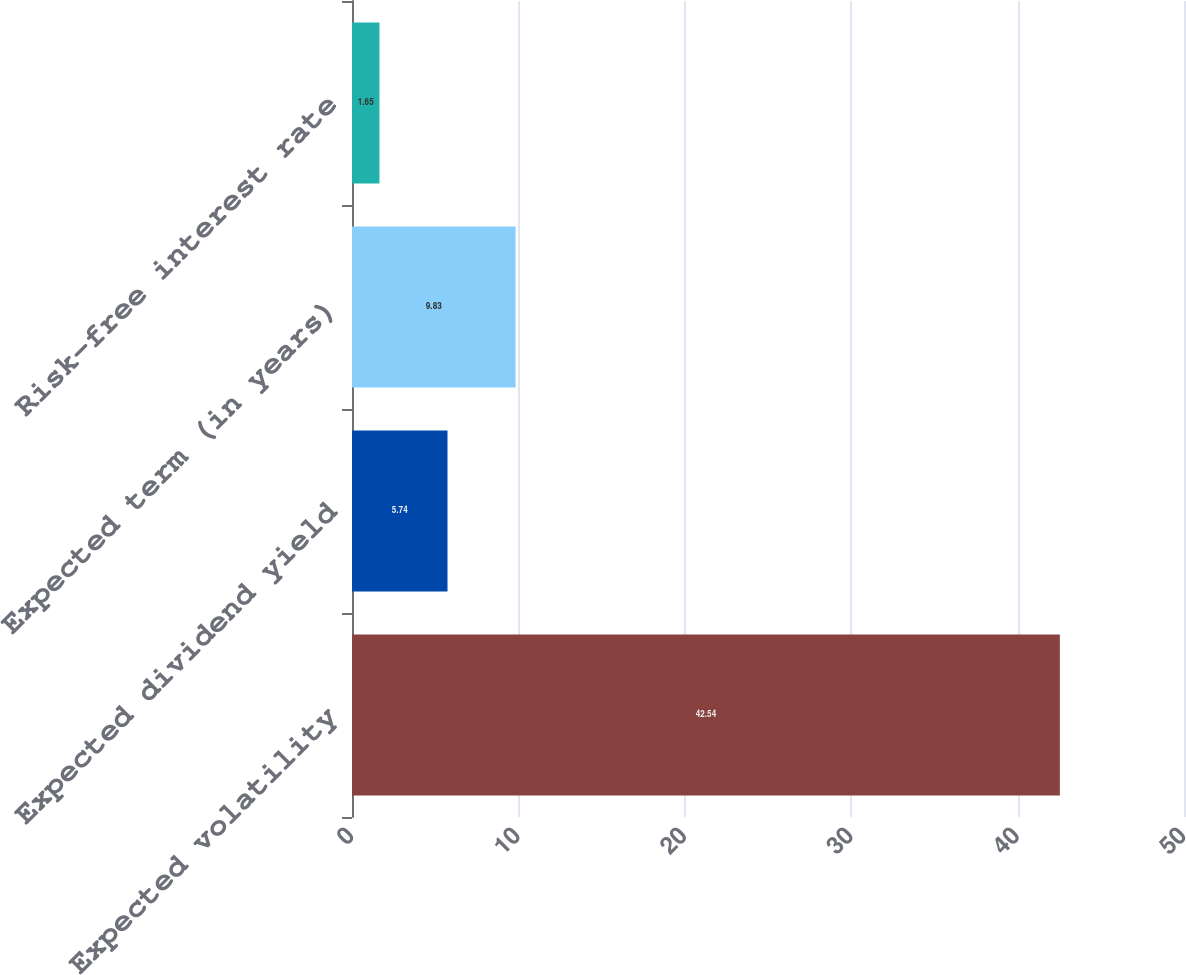Convert chart to OTSL. <chart><loc_0><loc_0><loc_500><loc_500><bar_chart><fcel>Expected volatility<fcel>Expected dividend yield<fcel>Expected term (in years)<fcel>Risk-free interest rate<nl><fcel>42.54<fcel>5.74<fcel>9.83<fcel>1.65<nl></chart> 